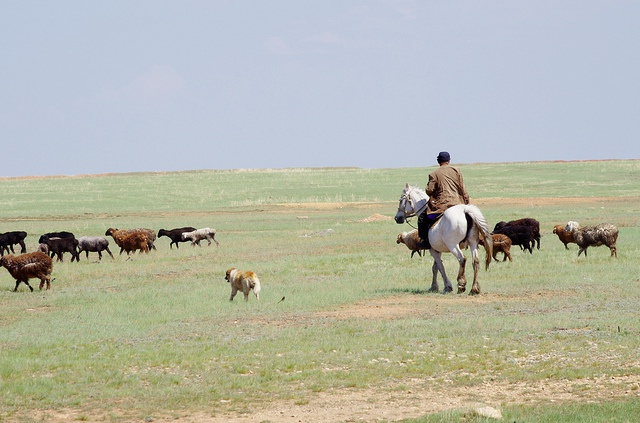Describe the objects in this image and their specific colors. I can see horse in lightgray, darkgray, gray, and black tones, people in lightgray, black, gray, tan, and maroon tones, sheep in lightgray, black, tan, and gray tones, sheep in lightgray, black, maroon, and gray tones, and sheep in lightgray, black, gray, maroon, and tan tones in this image. 